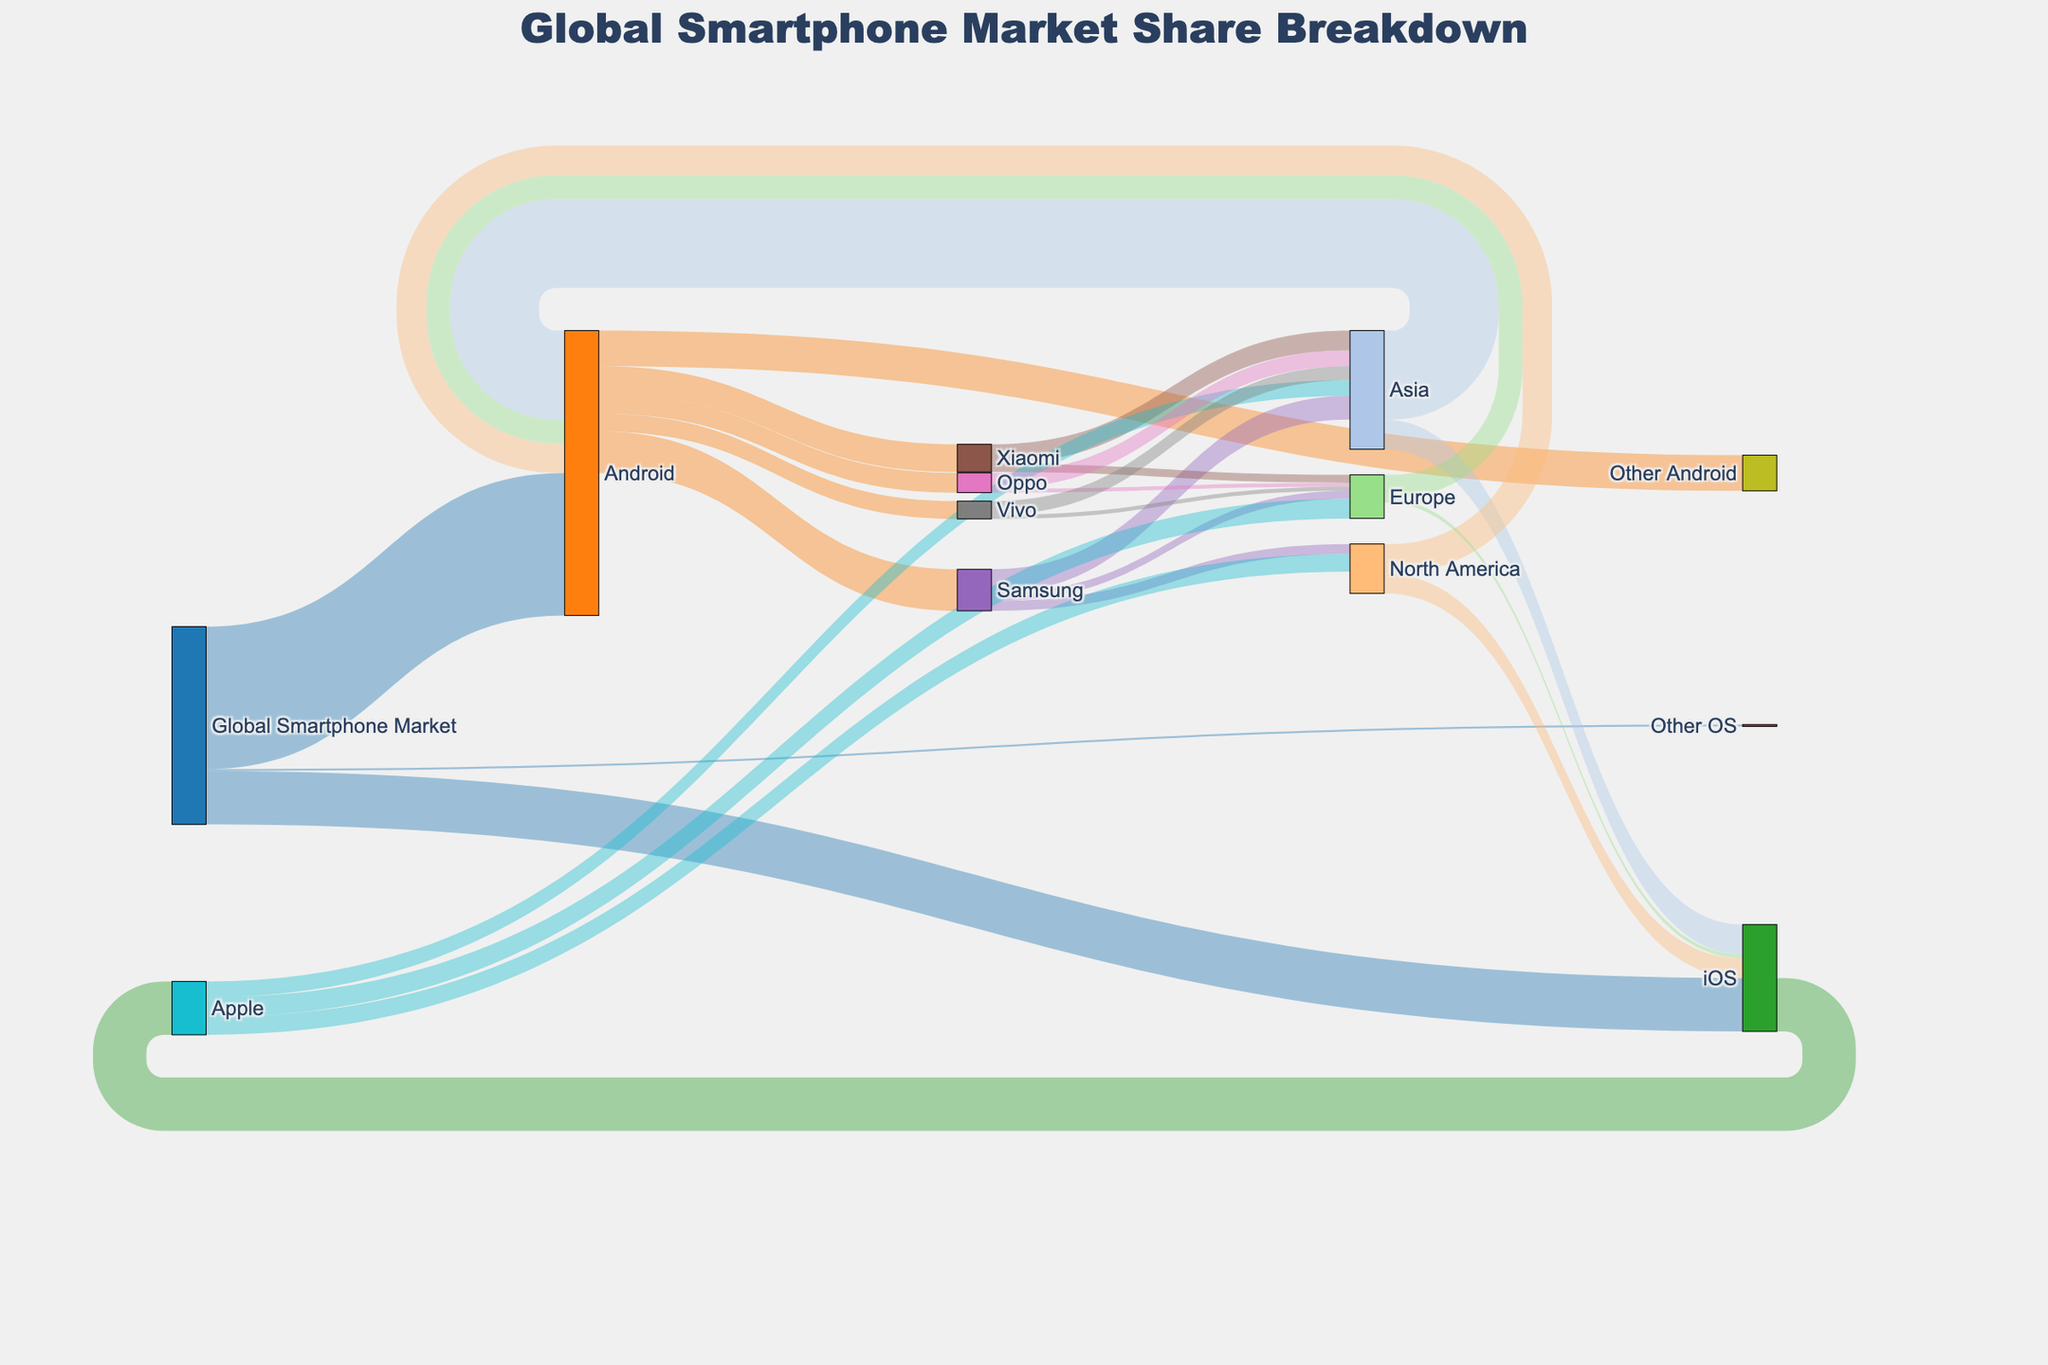What's the title of the figure? The title is displayed prominently at the top of the figure. It reads "Global Smartphone Market Share Breakdown".
Answer: Global Smartphone Market Share Breakdown Which brand under Android has the largest market share? By observing the width of the flows from "Android" to its associated brands, "Samsung" has the largest flow indicating it has the largest market share among Android brands.
Answer: Samsung Which operating system holds the majority of the global smartphone market share? The flows originating from the "Global Smartphone Market" and moving towards the different operating systems show that "Android" has the thickest flow, indicating the majority share.
Answer: Android What is the combined market share of Samsung and Apple in North America? Samsung's flow to North America has a value of 5, while Apple's flow to North America has a value of 9. Adding them up gives 5 + 9 = 14.
Answer: 14 How does the market share of Xiaomi in Europe compare to that in Asia? The Sankey diagram shows Xiaomi's flow to Europe is 4 and to Asia is 10. Xiaomi's market share in Asia is more than double compared to Europe.
Answer: Larger in Asia What is the total market share of iOS in Asia, North America, and Europe combined? The flows from "iOS" to different regions are 15 (Asia), 10 (North America), and 2 (Europe). Summing them up: 15 + 10 + 2 = 27.
Answer: 27 Which region has the highest market share of Android devices? The flows from "Android" to different regions show that Asia has the largest flow value of 45 compared to North America (15) and Europe (12).
Answer: Asia How many brands are included under the "Other Android" category? The "Other Android" category aggregates brands other than Samsung, Xiaomi, Oppo, and Vivo without specifying the exact number of brands, which cannot be determined from the plot directly.
Answer: Not specified in the figure What is the market share of Oppo in Europe? Observing the Sankey flow, Oppo's market share in Europe is represented by a flow with a value of 2.
Answer: 2 